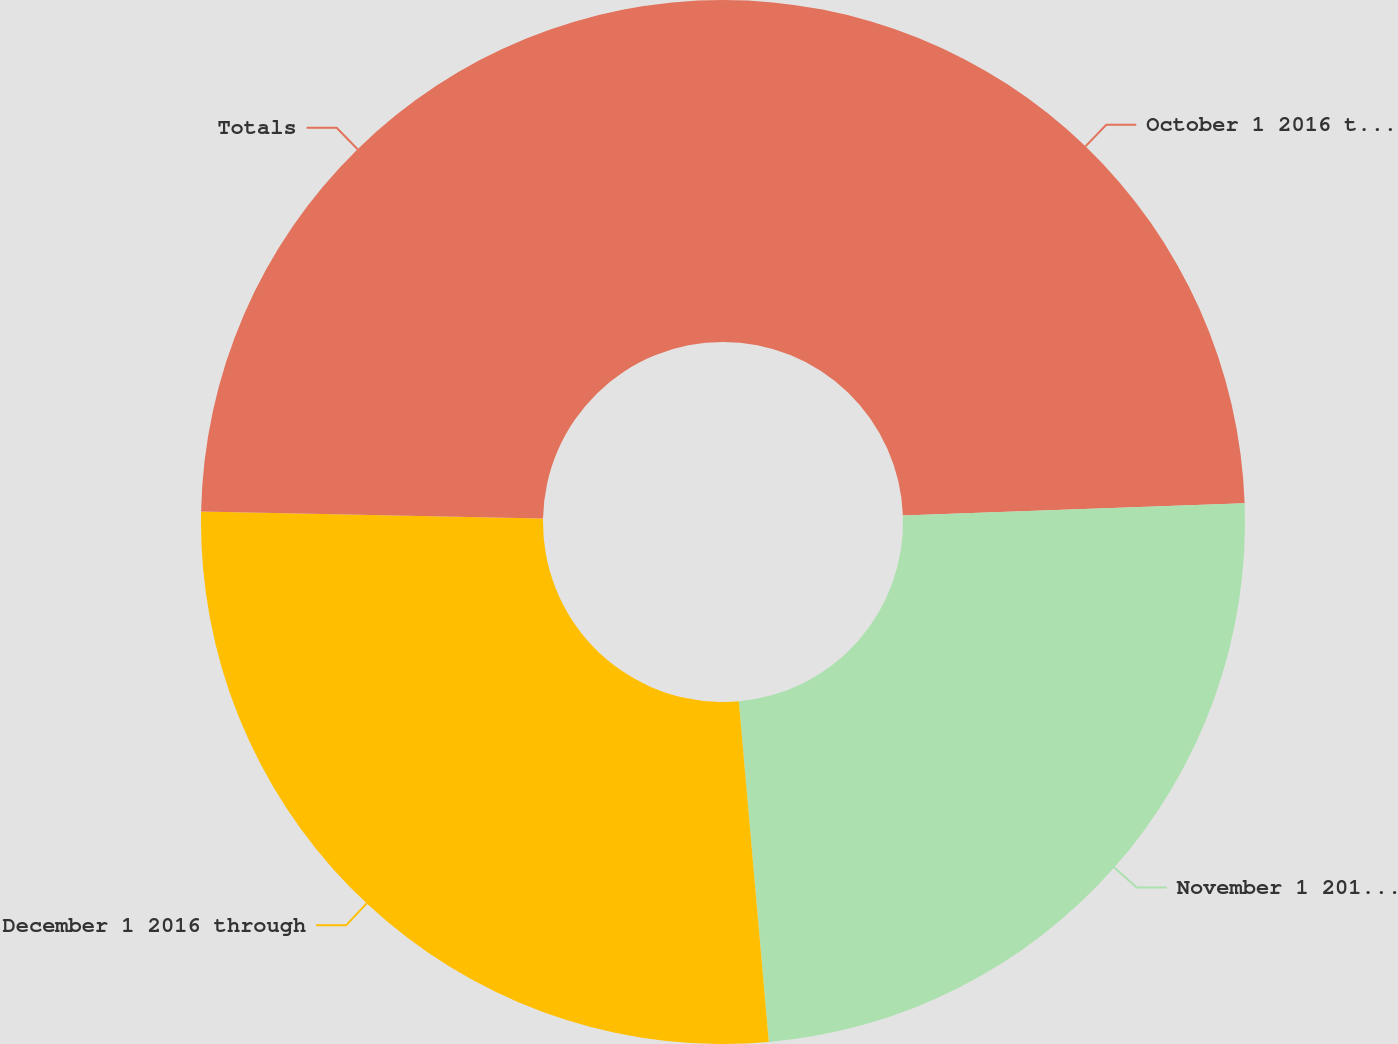Convert chart. <chart><loc_0><loc_0><loc_500><loc_500><pie_chart><fcel>October 1 2016 through October<fcel>November 1 2016 through<fcel>December 1 2016 through<fcel>Totals<nl><fcel>24.43%<fcel>24.17%<fcel>26.72%<fcel>24.68%<nl></chart> 